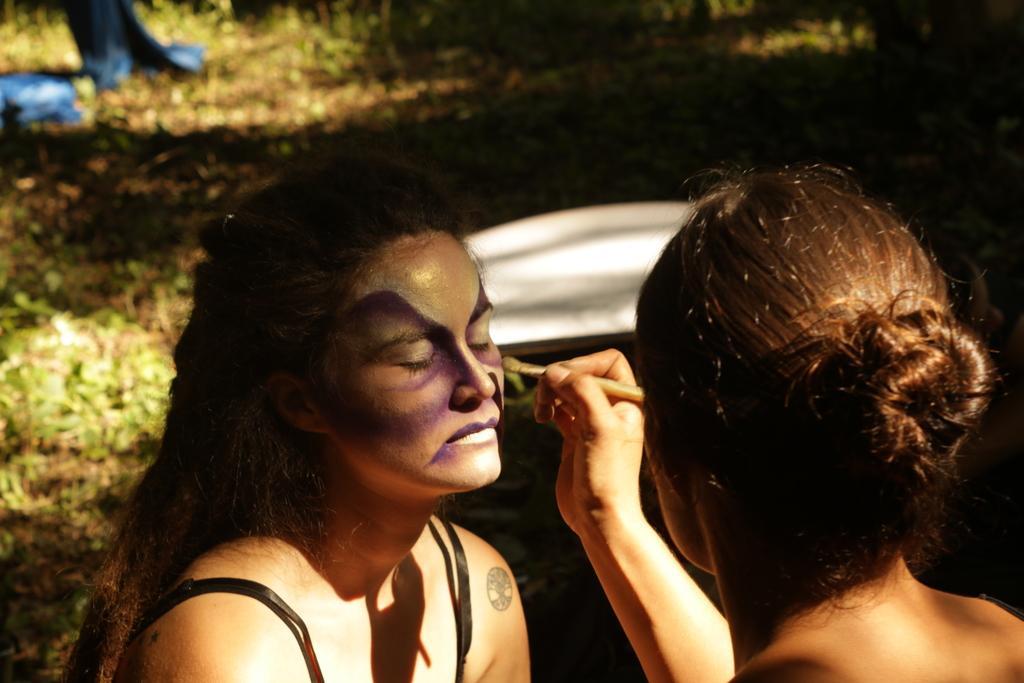Can you describe this image briefly? In this picture I can see 2 women in front and the women right is holding a brush in her hand and I see the paint on the face of the woman on the left and in the background I see the grass and on the top left of this image I see the blue color things. 